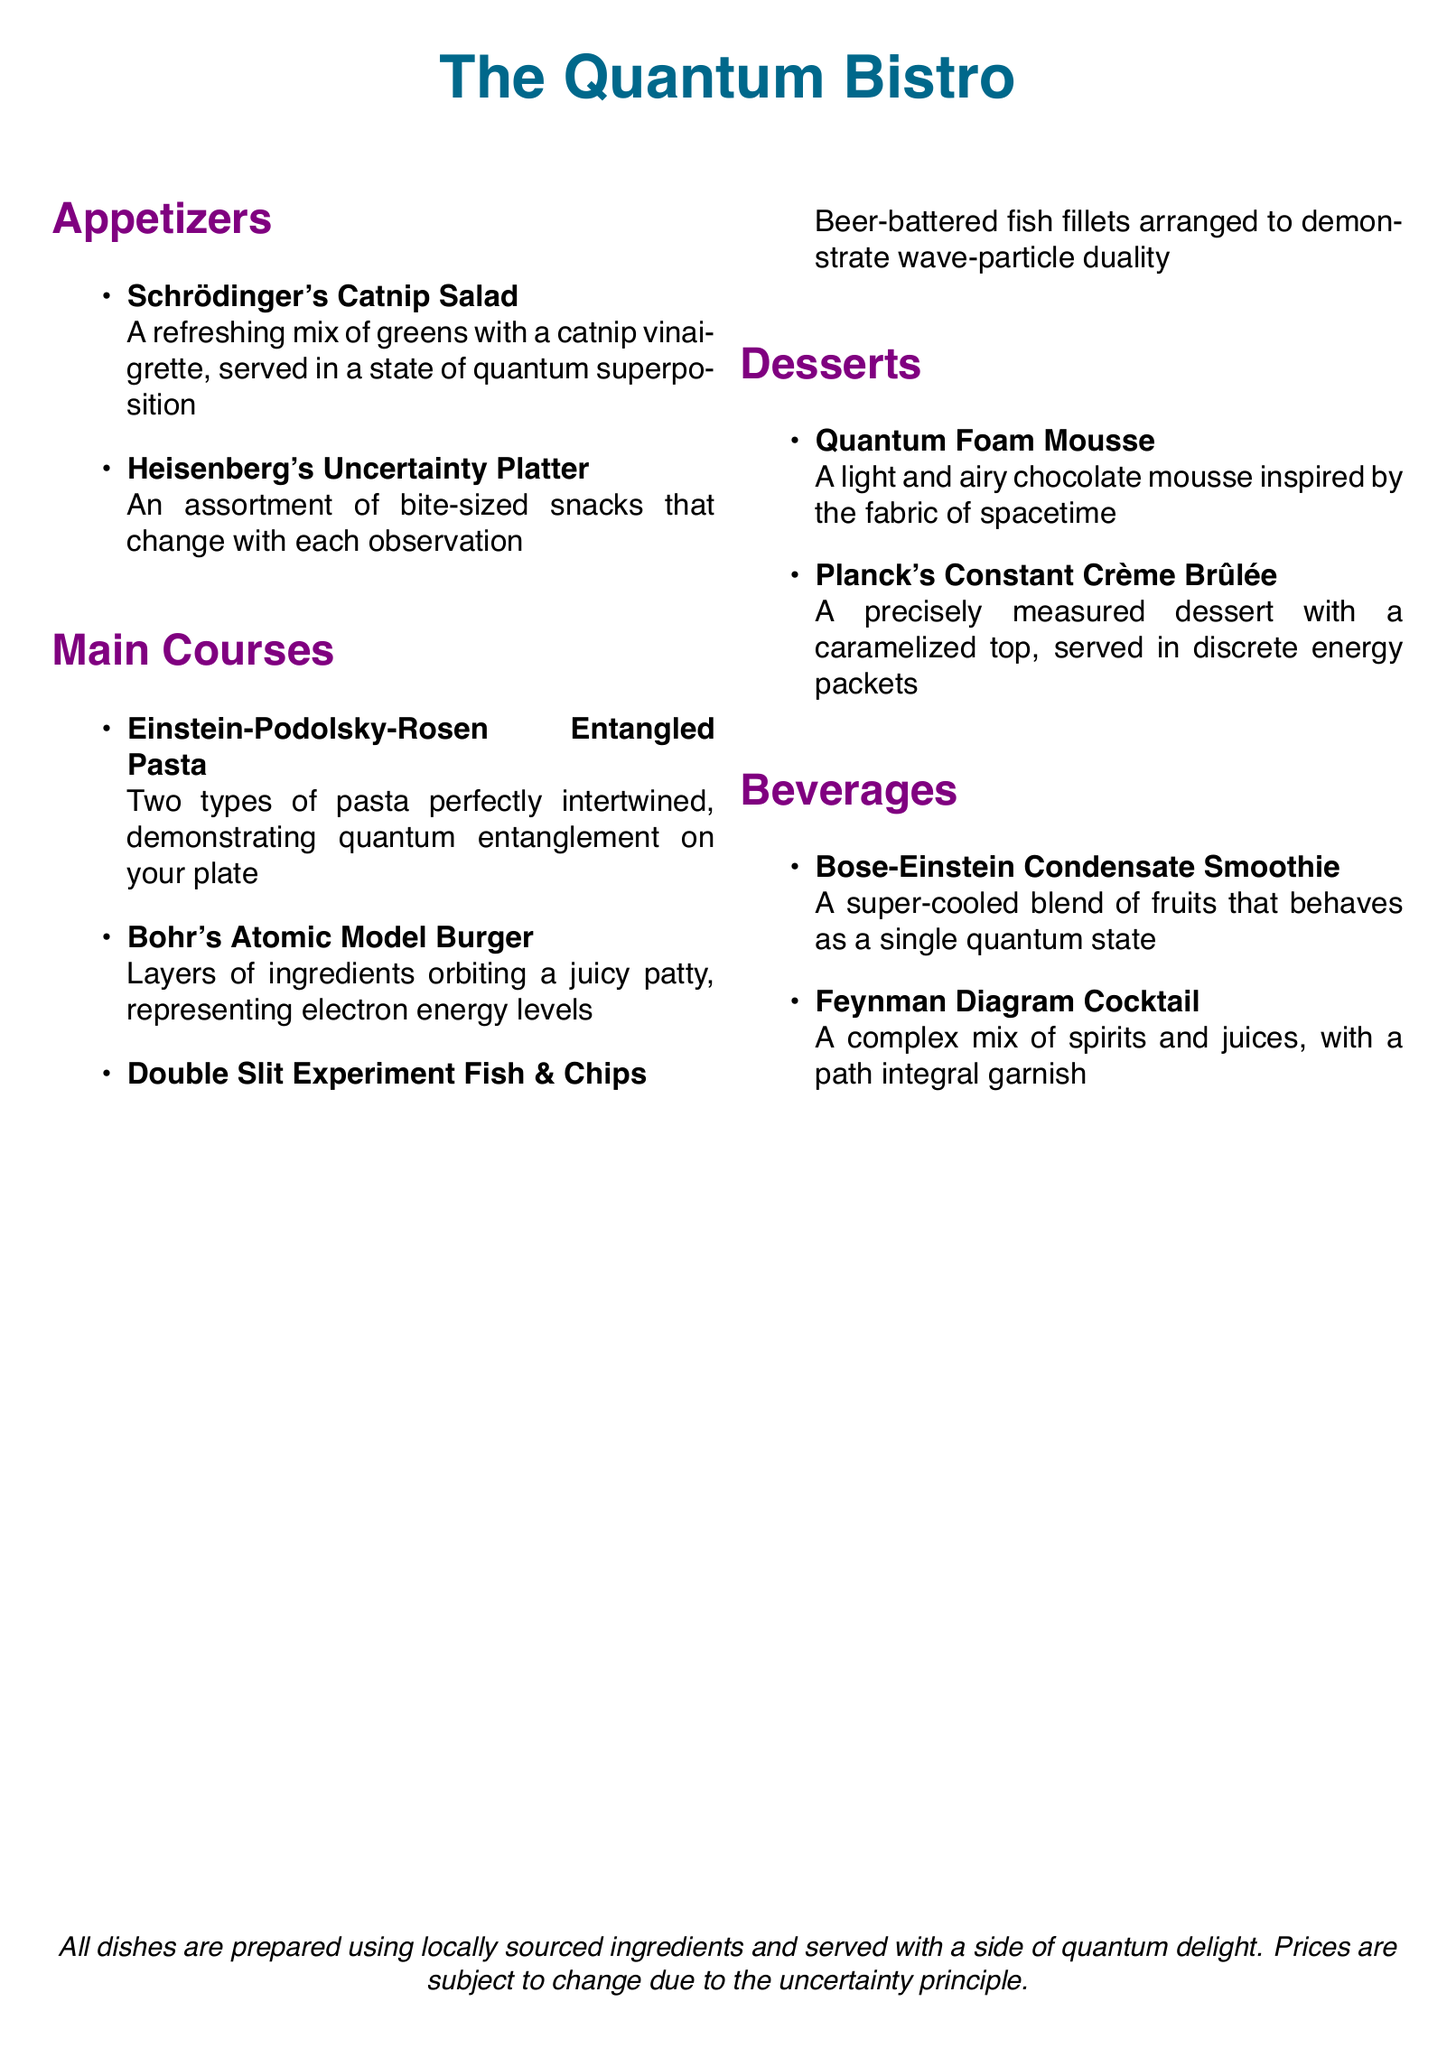What is the name of the appetizer that features a vinaigrette? The document lists "Schrödinger's Catnip Salad" as an appetizer with catnip vinaigrette.
Answer: Schrödinger's Catnip Salad How many main course dishes are listed? The document shows three main courses: Einstein-Podolsky-Rosen Entangled Pasta, Bohr's Atomic Model Burger, and Double Slit Experiment Fish & Chips.
Answer: Three What dessert is inspired by spacetime? The dessert that draws inspiration from the fabric of spacetime is "Quantum Foam Mousse."
Answer: Quantum Foam Mousse What is the title of the restaurant? The title of the restaurant is prominently displayed as "The Quantum Bistro."
Answer: The Quantum Bistro Which beverage is a smoothie? The document states that "Bose-Einstein Condensate Smoothie" is the smoothie offered on the menu.
Answer: Bose-Einstein Condensate Smoothie What is the unique property of the Heisenberg's Uncertainty Platter? The platter features snacks that change with observations, demonstrating uncertainty in its nature.
Answer: Changes with each observation Which dessert has a caramelized top? "Planck's Constant Crème Brûlée" is described as having a caramelized top.
Answer: Planck's Constant Crème Brûlée What is hinted at regarding dish prices? The document mentions that prices are subject to change due to the uncertainty principle, indicating variability.
Answer: Uncertainty principle 